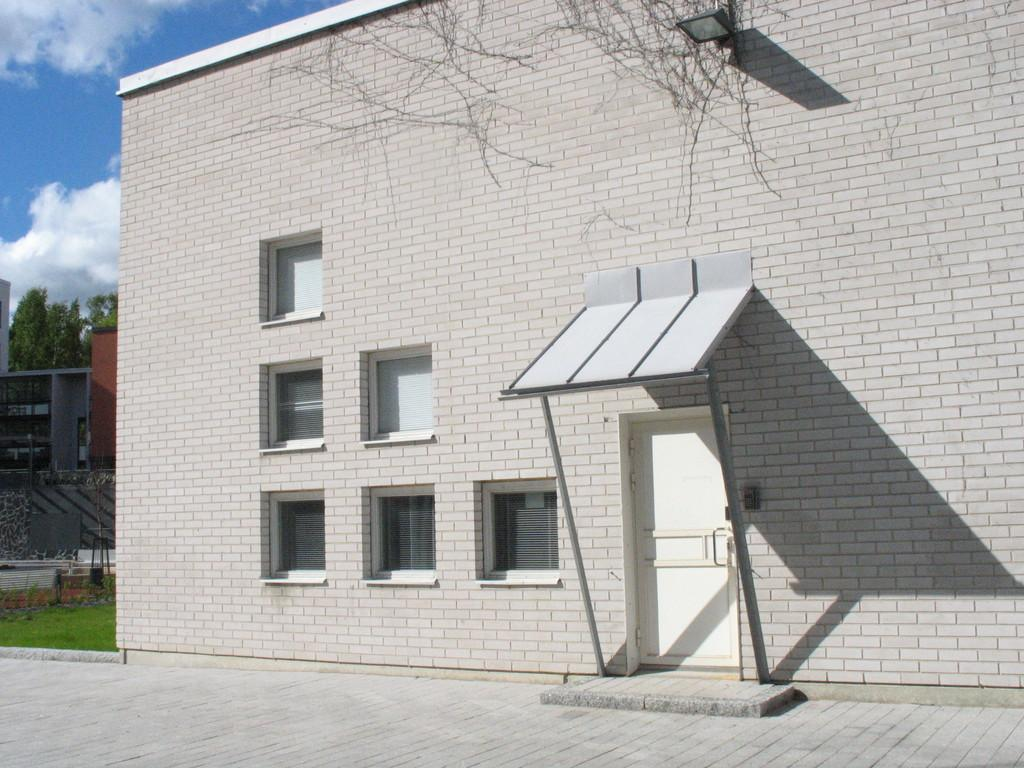What is the main structure visible in the foreground of the image? There is a house structure in the foreground of the image. What can be seen in the background of the image? There are buildings, trees, grassland, and the sky visible in the background of the image. What type of cast can be seen on the dinner table in the image? There is no cast or dinner table present in the image. How many thumbs are visible on the grassland in the image? Thumbs are not visible in the image, as they are body parts of humans and not present in the scene. 